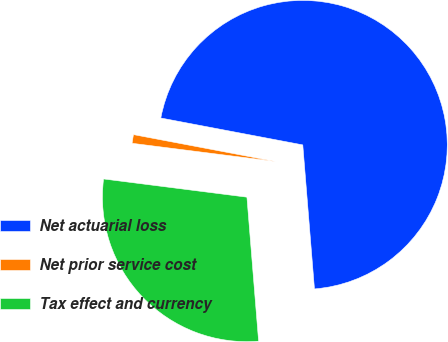Convert chart to OTSL. <chart><loc_0><loc_0><loc_500><loc_500><pie_chart><fcel>Net actuarial loss<fcel>Net prior service cost<fcel>Tax effect and currency<nl><fcel>70.73%<fcel>0.97%<fcel>28.3%<nl></chart> 